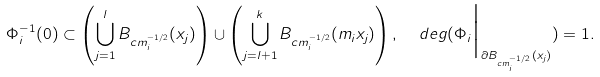<formula> <loc_0><loc_0><loc_500><loc_500>\Phi _ { i } ^ { - 1 } ( 0 ) \subset \left ( \bigcup _ { j = 1 } ^ { l } B _ { c m _ { i } ^ { - 1 / 2 } } ( x _ { j } ) \right ) \cup \left ( \bigcup _ { j = l + 1 } ^ { k } B _ { c m _ { i } ^ { - 1 / 2 } } ( m _ { i } x _ { j } ) \right ) , \ \ d e g ( \Phi _ { i } \Big | _ { \partial B _ { c m _ { i } ^ { - 1 / 2 } } ( x _ { j } ) } ) = 1 .</formula> 